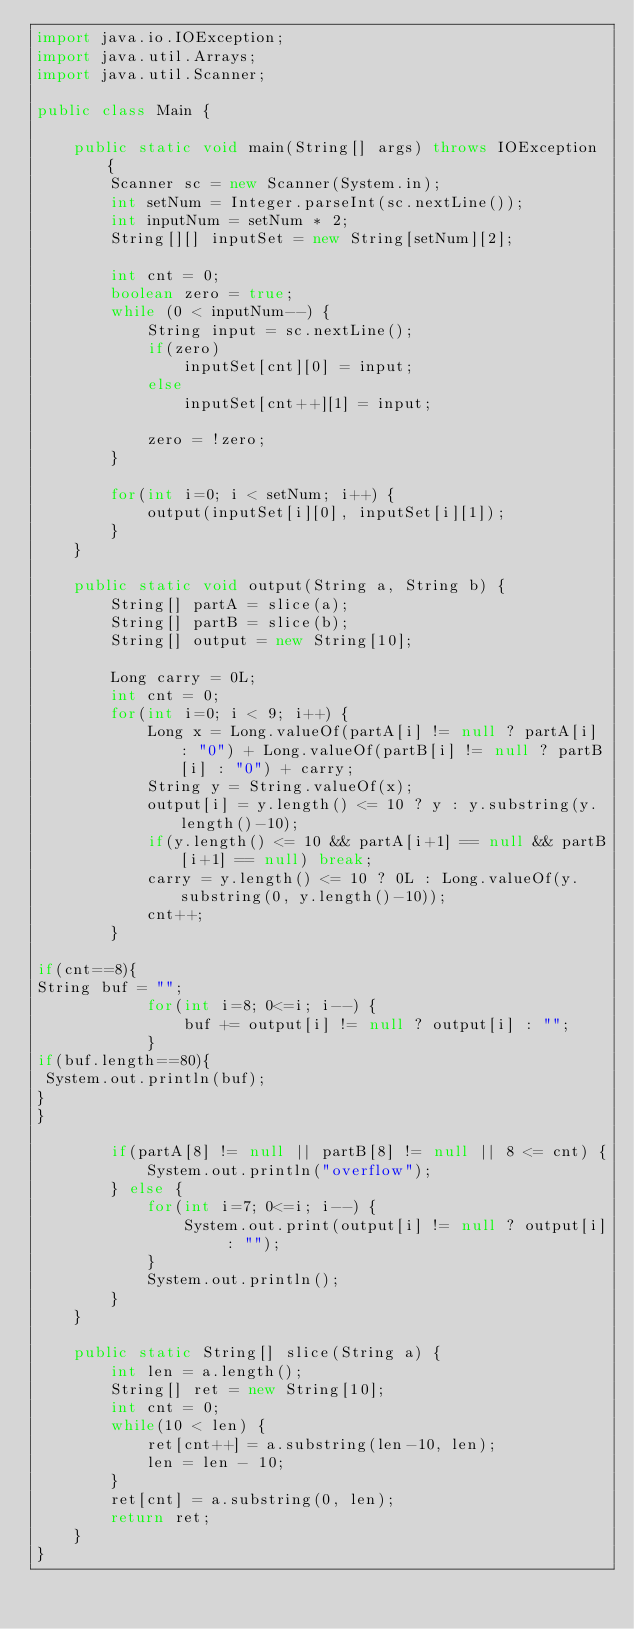<code> <loc_0><loc_0><loc_500><loc_500><_Java_>import java.io.IOException;
import java.util.Arrays;
import java.util.Scanner;
 
public class Main {
 
    public static void main(String[] args) throws IOException {
        Scanner sc = new Scanner(System.in);
        int setNum = Integer.parseInt(sc.nextLine());
        int inputNum = setNum * 2;
        String[][] inputSet = new String[setNum][2];
 
        int cnt = 0;
        boolean zero = true;
        while (0 < inputNum--) {
            String input = sc.nextLine();
            if(zero)
                inputSet[cnt][0] = input;
            else
                inputSet[cnt++][1] = input;
 
            zero = !zero;
        }
 
        for(int i=0; i < setNum; i++) {
            output(inputSet[i][0], inputSet[i][1]);
        }
    }
 
    public static void output(String a, String b) {
        String[] partA = slice(a);
        String[] partB = slice(b);
        String[] output = new String[10];
 
        Long carry = 0L;
        int cnt = 0;
        for(int i=0; i < 9; i++) {
            Long x = Long.valueOf(partA[i] != null ? partA[i] : "0") + Long.valueOf(partB[i] != null ? partB[i] : "0") + carry;
            String y = String.valueOf(x);
            output[i] = y.length() <= 10 ? y : y.substring(y.length()-10);
            if(y.length() <= 10 && partA[i+1] == null && partB[i+1] == null) break;
            carry = y.length() <= 10 ? 0L : Long.valueOf(y.substring(0, y.length()-10));
            cnt++;
        }
 
if(cnt==8){
String buf = "";
            for(int i=8; 0<=i; i--) {
                buf += output[i] != null ? output[i] : "";
            }
if(buf.length==80){
 System.out.println(buf);
}
}

        if(partA[8] != null || partB[8] != null || 8 <= cnt) {
            System.out.println("overflow");
        } else {
            for(int i=7; 0<=i; i--) {
                System.out.print(output[i] != null ? output[i] : "");
            }
            System.out.println();
        }
    }
 
    public static String[] slice(String a) {
        int len = a.length();
        String[] ret = new String[10];
        int cnt = 0;
        while(10 < len) {
            ret[cnt++] = a.substring(len-10, len);
            len = len - 10;
        }
        ret[cnt] = a.substring(0, len);
        return ret;
    }
}</code> 